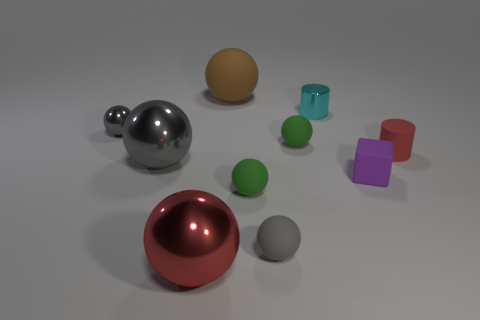Subtract all cyan cylinders. How many gray balls are left? 3 Subtract 2 balls. How many balls are left? 5 Subtract all green balls. How many balls are left? 5 Subtract all big metallic spheres. How many spheres are left? 5 Subtract all blue spheres. Subtract all purple blocks. How many spheres are left? 7 Subtract all balls. How many objects are left? 3 Subtract all big purple metal cylinders. Subtract all green matte spheres. How many objects are left? 8 Add 3 tiny shiny cylinders. How many tiny shiny cylinders are left? 4 Add 4 green rubber cubes. How many green rubber cubes exist? 4 Subtract 0 cyan balls. How many objects are left? 10 